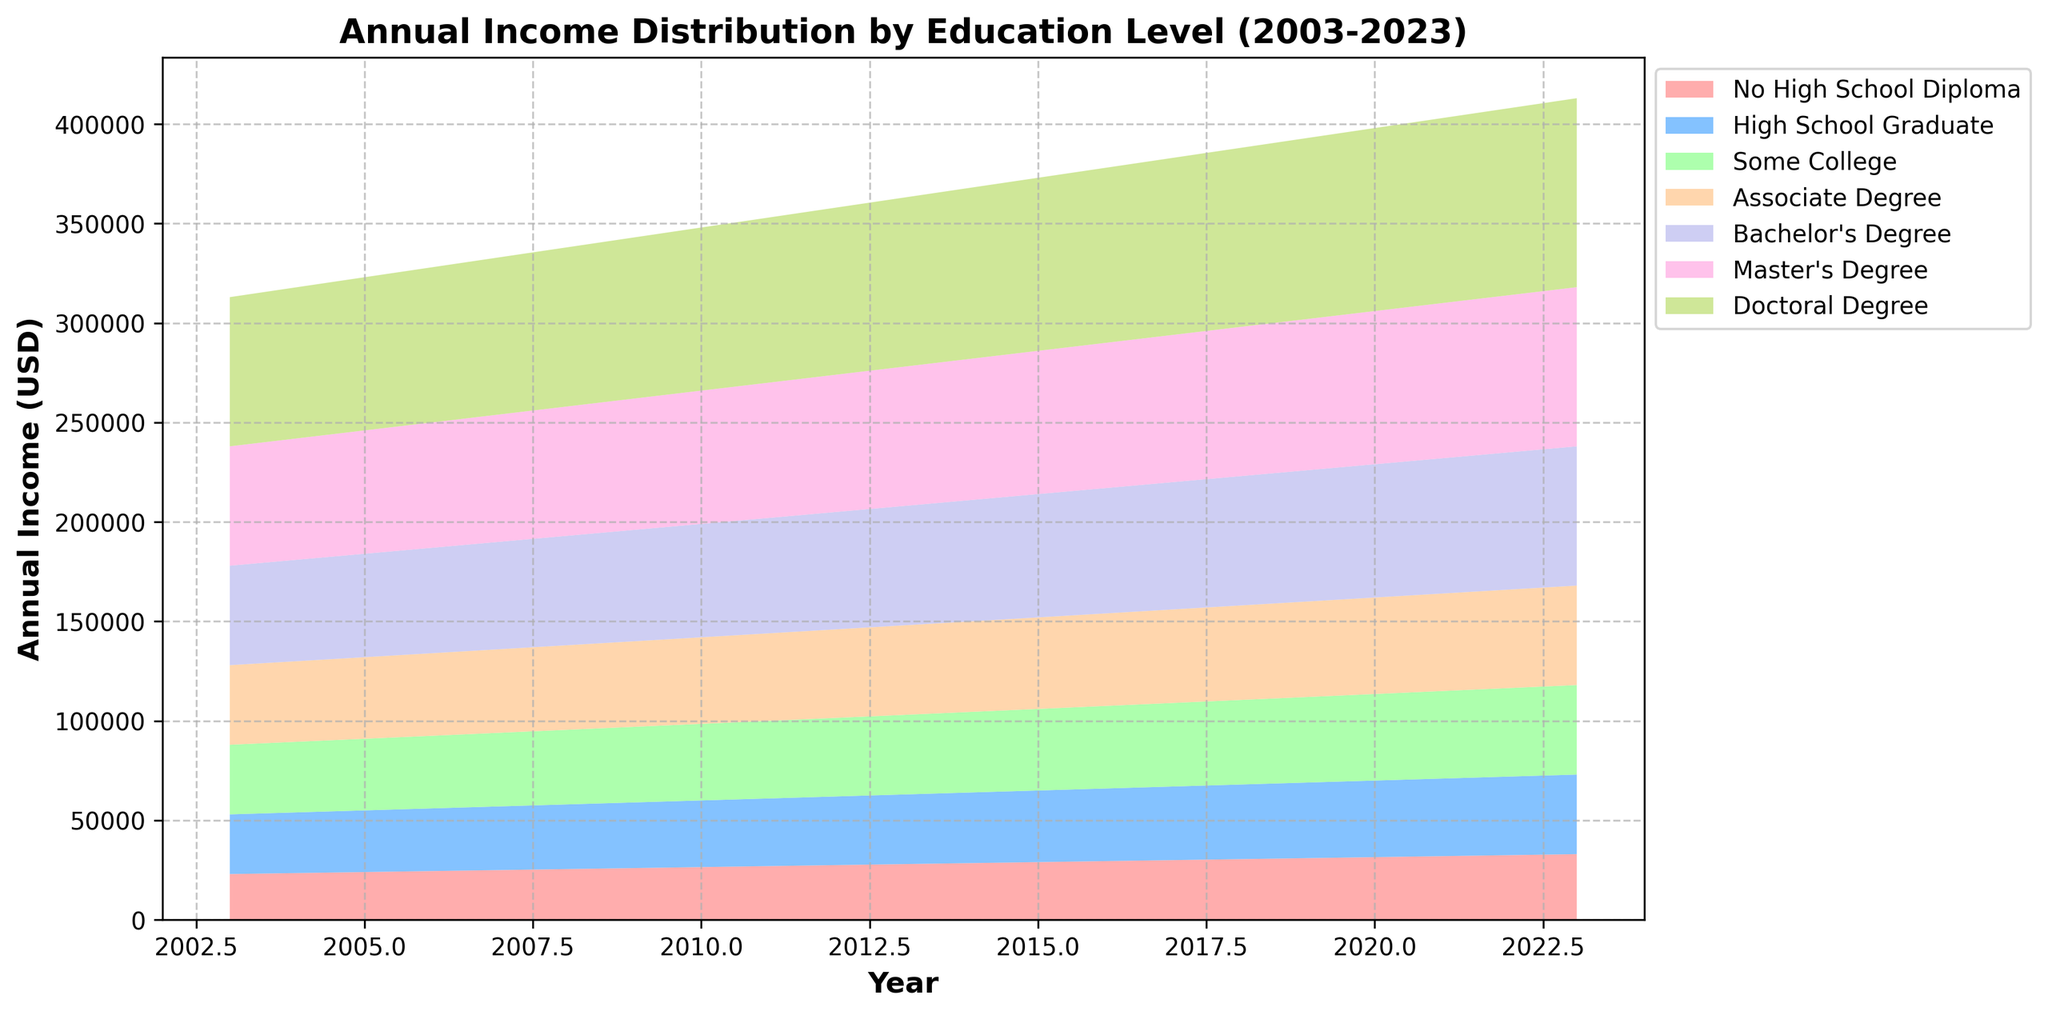How has the income for bachelor’s degree holders changed from 2003 to 2023? To find the income change, subtract the income in 2003 from the income in 2023 for bachelor’s degree holders. The income in 2023 is $70,000 and in 2003 it was $50,000. So, the change is $70,000 - $50,000 = $20,000.
Answer: $20,000 Which education level had the lowest income in 2010? To determine the education level with the lowest income in 2010, locate the income figures for each education level in that year. The lowest income in 2010 is for "No High School Diploma," with an income of $26,500.
Answer: No High School Diploma Compare the income of master’s degree holders and associate degree holders in 2015. To compare, locate the incomes for both master’s and associate degree holders in 2015. Master’s degree holders had an income of $72,000, while associate degree holders had $46,000. $72,000 is greater than $46,000.
Answer: Master’s degree holders had higher income What is the average annual income of doctoral degree holders from 2003 to 2023? To find the average, sum the incomes over the years and divide by the number of years. The sum is (75,000 + 76,000 + 77,000 + 78,000 + 79,000 + 80,000 + 81,000 + 82,000 + 83,000 + 84,000 + 85,000 + 86,000 + 87,000 + 88,000 + 89,000 + 90,000 + 91,000 + 92,000 + 93,000 + 94,000 + 95,000) = 1,749,000. There are 21 years, so the average is 1,749,000 / 21 = 83,285.71.
Answer: $83,285.71 Which education level shows the greatest absolute increase in income over the 20-year period? To determine the greatest absolute increase, subtract the 2003 income from the 2023 income for each education level and compare. The highest increase is for the doctoral degree: 95,000 (2023) - 75,000 (2003) = 20,000. Similar calculations for other levels show smaller increases.
Answer: Doctoral Degree Did any education level’s income decrease over the years? To check for any decrease, examine the income values for each education level from 2003 to 2023. None of the education levels show a decreasing trend. Every education level shows an increasing trend over the years.
Answer: No In what year did the income for some college exceed $40,000? Locate the income figures for "Some College" and identify the year this level first exceeded $40,000. Checking each year, it first surpasses $40,000 in 2013 with an income of $40,000.
Answer: 2013 How much more did master's degree holders earn than high school graduates in 2007? Subtract the income of high school graduates from the income of master's degree holders in 2007: $64,000 (Master's Degree) - $32,000 (High School Graduate) = $32,000.
Answer: $32,000 What was the income growth percentage for associate degree holders from 2003 to 2023? To calculate the percentage growth, use the formula [(Final Value - Initial Value) / Initial Value] * 100. For associate degree holders, it is [(50,000 - 40,000) / 40,000] * 100 = 25%.
Answer: 25% 